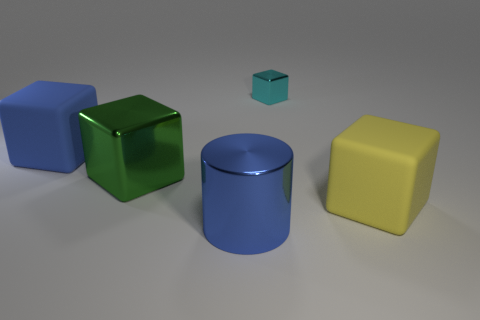Add 3 rubber objects. How many objects exist? 8 Subtract all big green metal blocks. How many blocks are left? 3 Subtract 3 cubes. How many cubes are left? 1 Add 2 green metallic blocks. How many green metallic blocks are left? 3 Add 4 big purple rubber spheres. How many big purple rubber spheres exist? 4 Subtract all blue cubes. How many cubes are left? 3 Subtract 0 purple cubes. How many objects are left? 5 Subtract all cylinders. How many objects are left? 4 Subtract all green cubes. Subtract all green cylinders. How many cubes are left? 3 Subtract all gray cylinders. How many green cubes are left? 1 